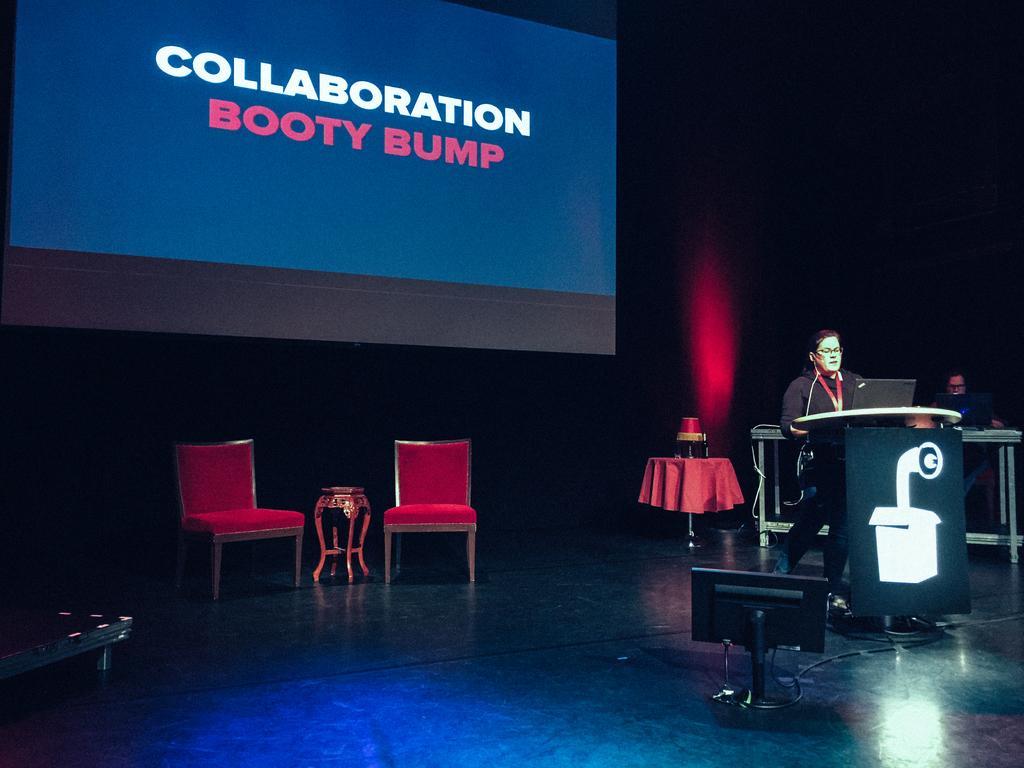Describe this image in one or two sentences. Here we can see a woman standing near the speech desk with a laptop in front of her and on the stage we can see a monitor and behind her we can see a table and couple of chairs and a projector screen 